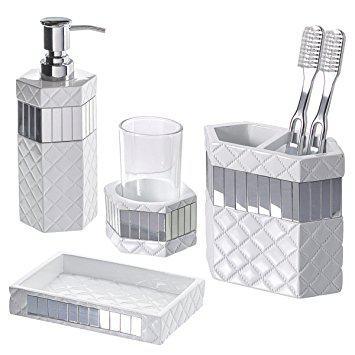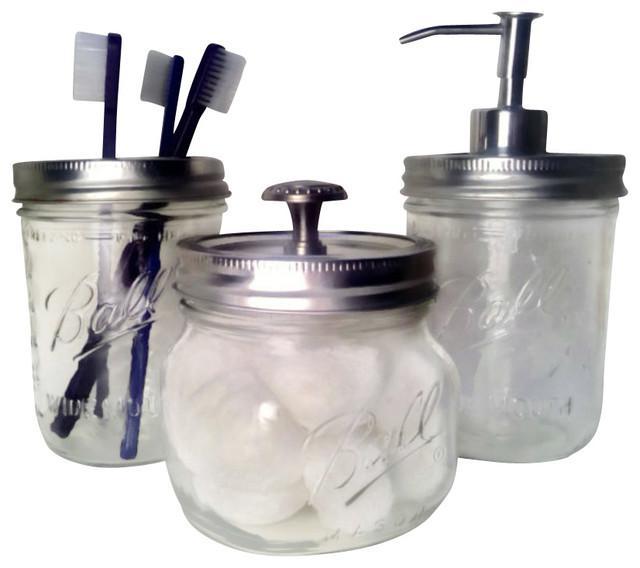The first image is the image on the left, the second image is the image on the right. Analyze the images presented: Is the assertion "An image shows a grouping of four coordinating vanity pieces, with a pump dispenser on the far left." valid? Answer yes or no. Yes. The first image is the image on the left, the second image is the image on the right. Assess this claim about the two images: "None of the objects are brown in color". Correct or not? Answer yes or no. Yes. 